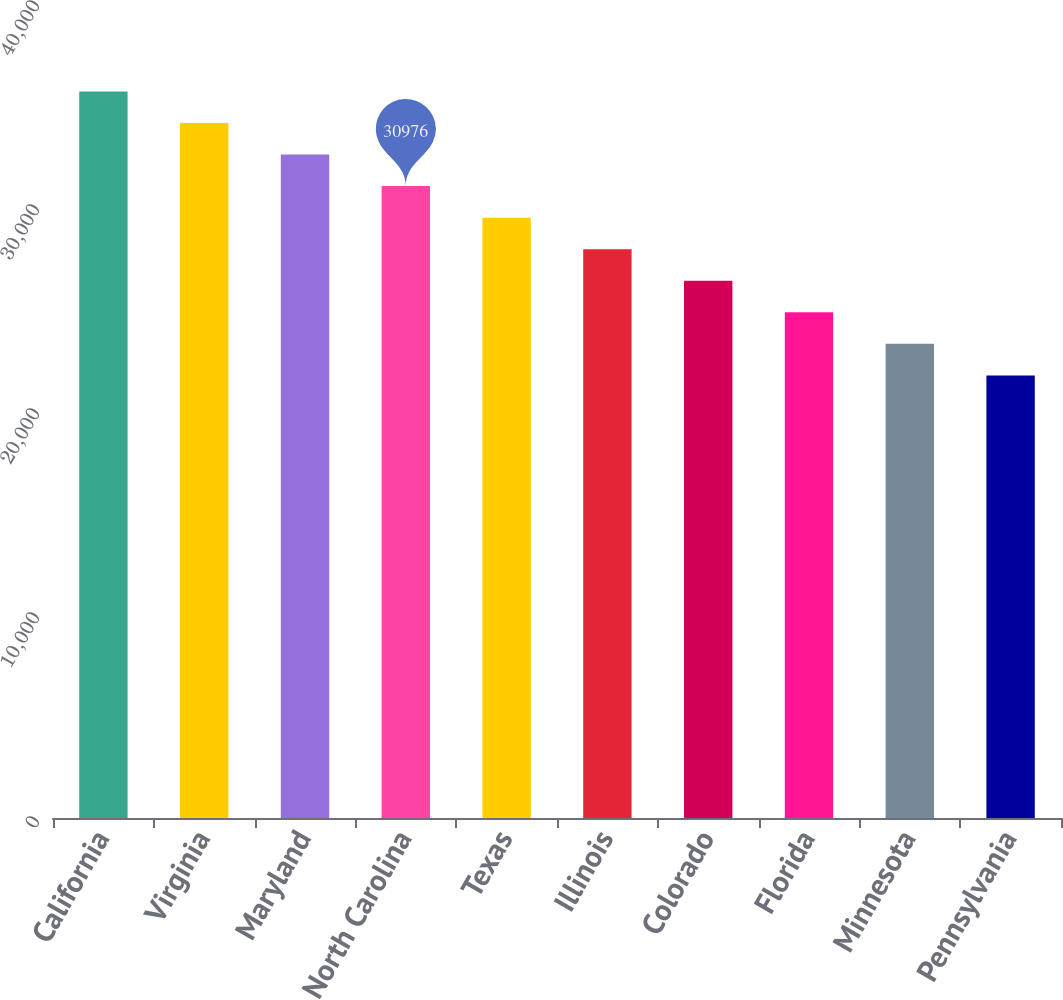Convert chart. <chart><loc_0><loc_0><loc_500><loc_500><bar_chart><fcel>California<fcel>Virginia<fcel>Maryland<fcel>North Carolina<fcel>Texas<fcel>Illinois<fcel>Colorado<fcel>Florida<fcel>Minnesota<fcel>Pennsylvania<nl><fcel>35616.4<fcel>34069.6<fcel>32522.8<fcel>30976<fcel>29429.2<fcel>27882.4<fcel>26335.6<fcel>24788.8<fcel>23242<fcel>21695.2<nl></chart> 